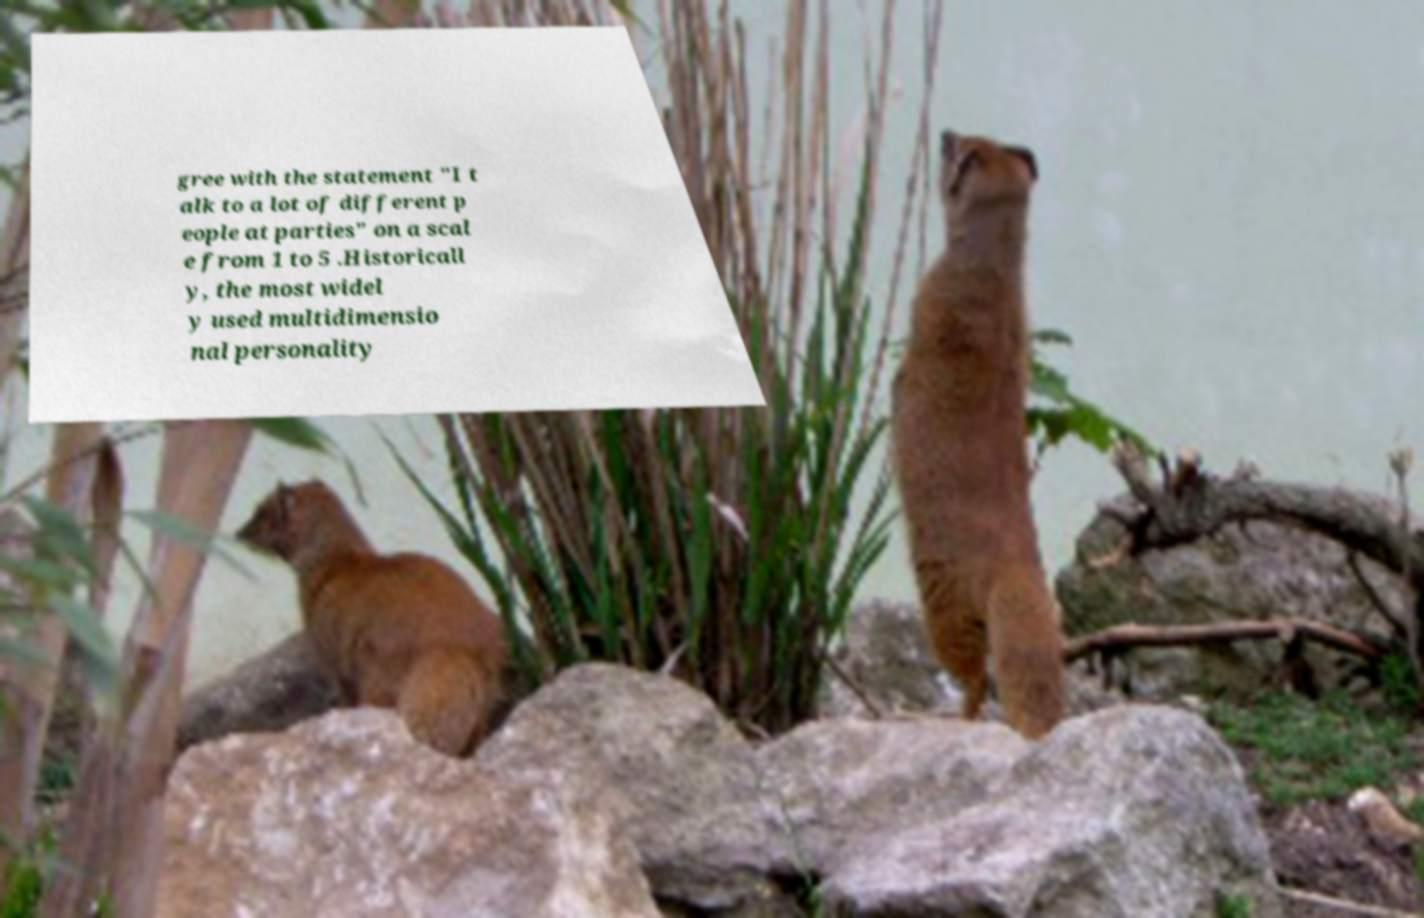For documentation purposes, I need the text within this image transcribed. Could you provide that? gree with the statement "I t alk to a lot of different p eople at parties" on a scal e from 1 to 5 .Historicall y, the most widel y used multidimensio nal personality 